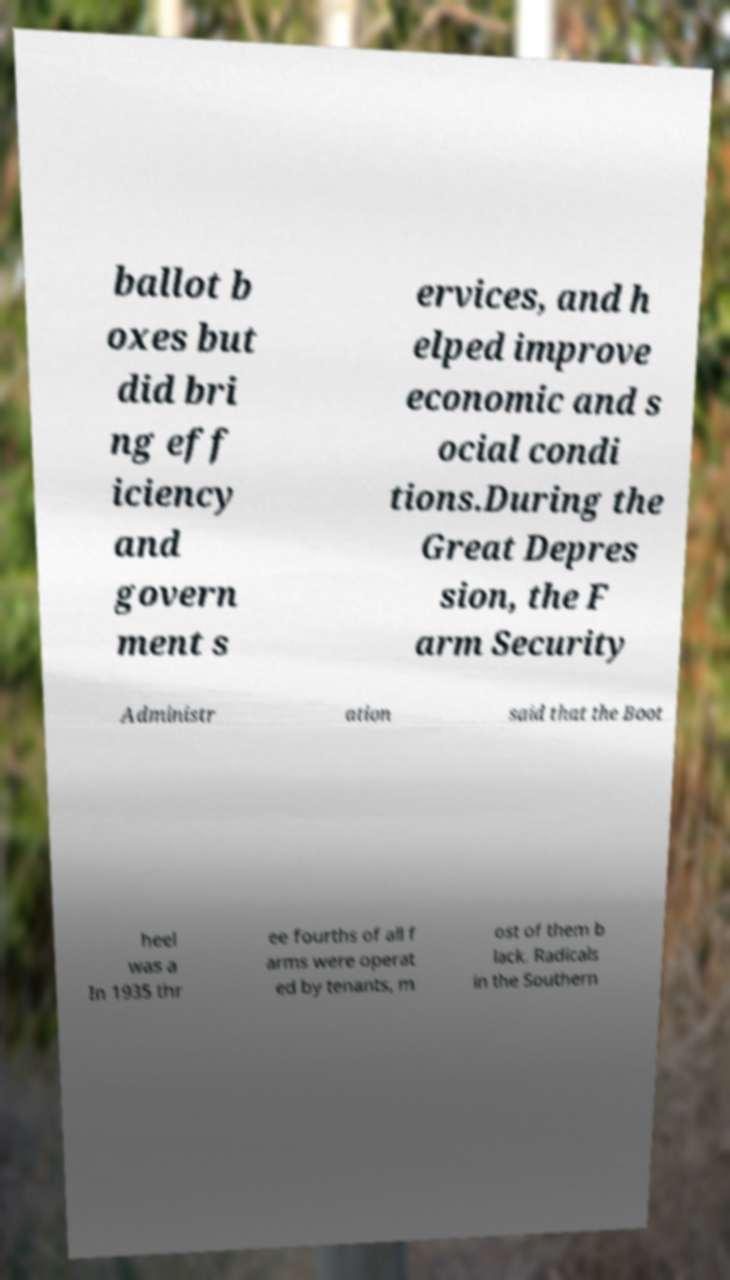Can you accurately transcribe the text from the provided image for me? ballot b oxes but did bri ng eff iciency and govern ment s ervices, and h elped improve economic and s ocial condi tions.During the Great Depres sion, the F arm Security Administr ation said that the Boot heel was a In 1935 thr ee fourths of all f arms were operat ed by tenants, m ost of them b lack. Radicals in the Southern 